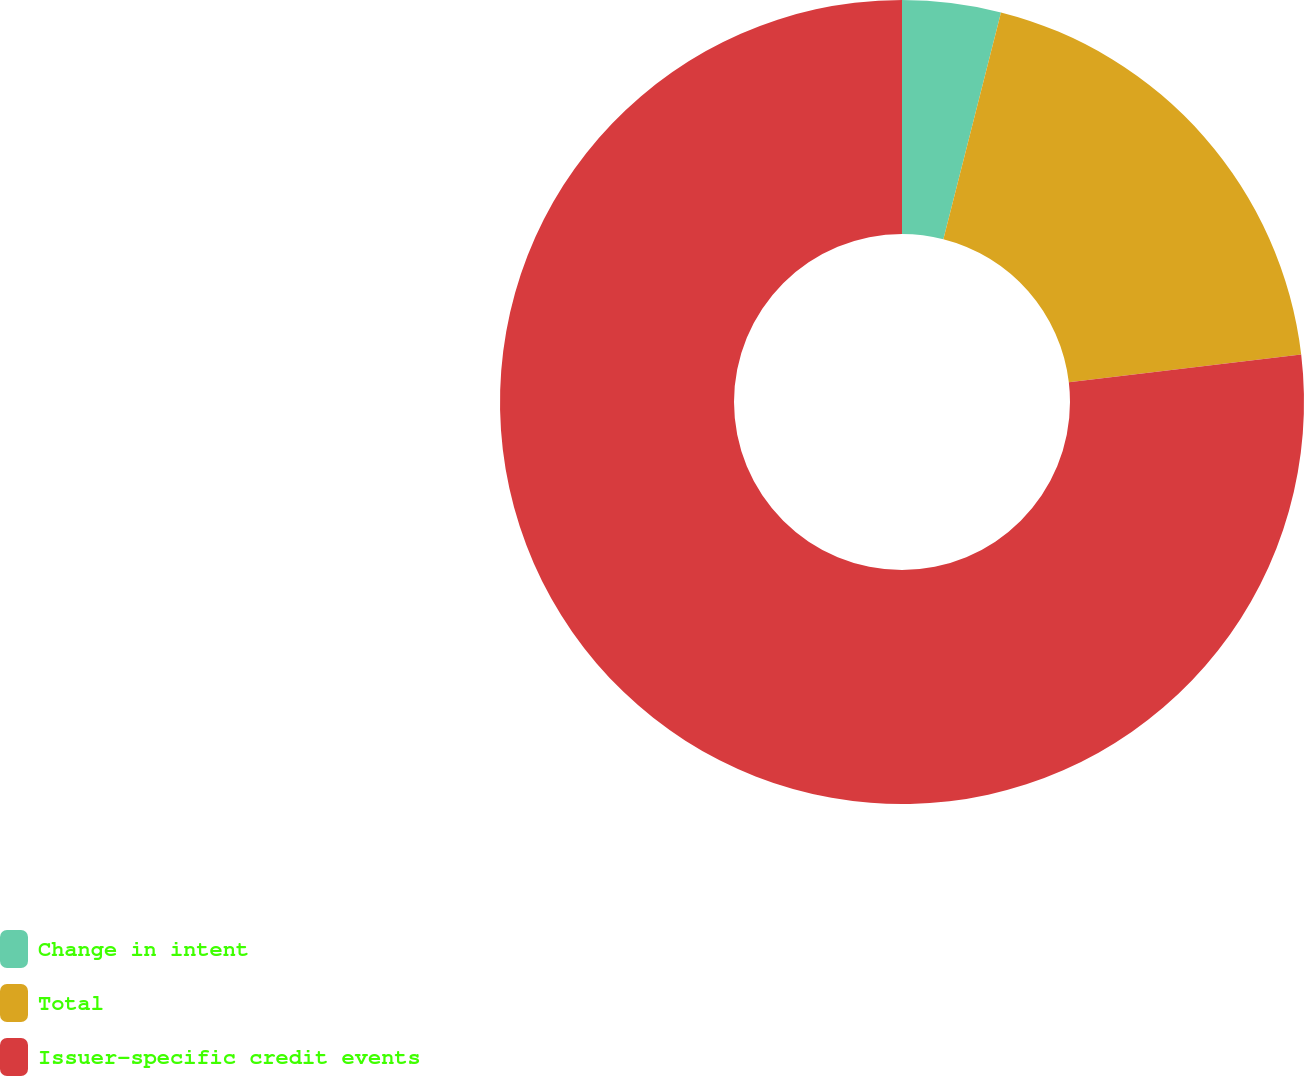<chart> <loc_0><loc_0><loc_500><loc_500><pie_chart><fcel>Change in intent<fcel>Total<fcel>Issuer-specific credit events<nl><fcel>3.96%<fcel>19.16%<fcel>76.88%<nl></chart> 